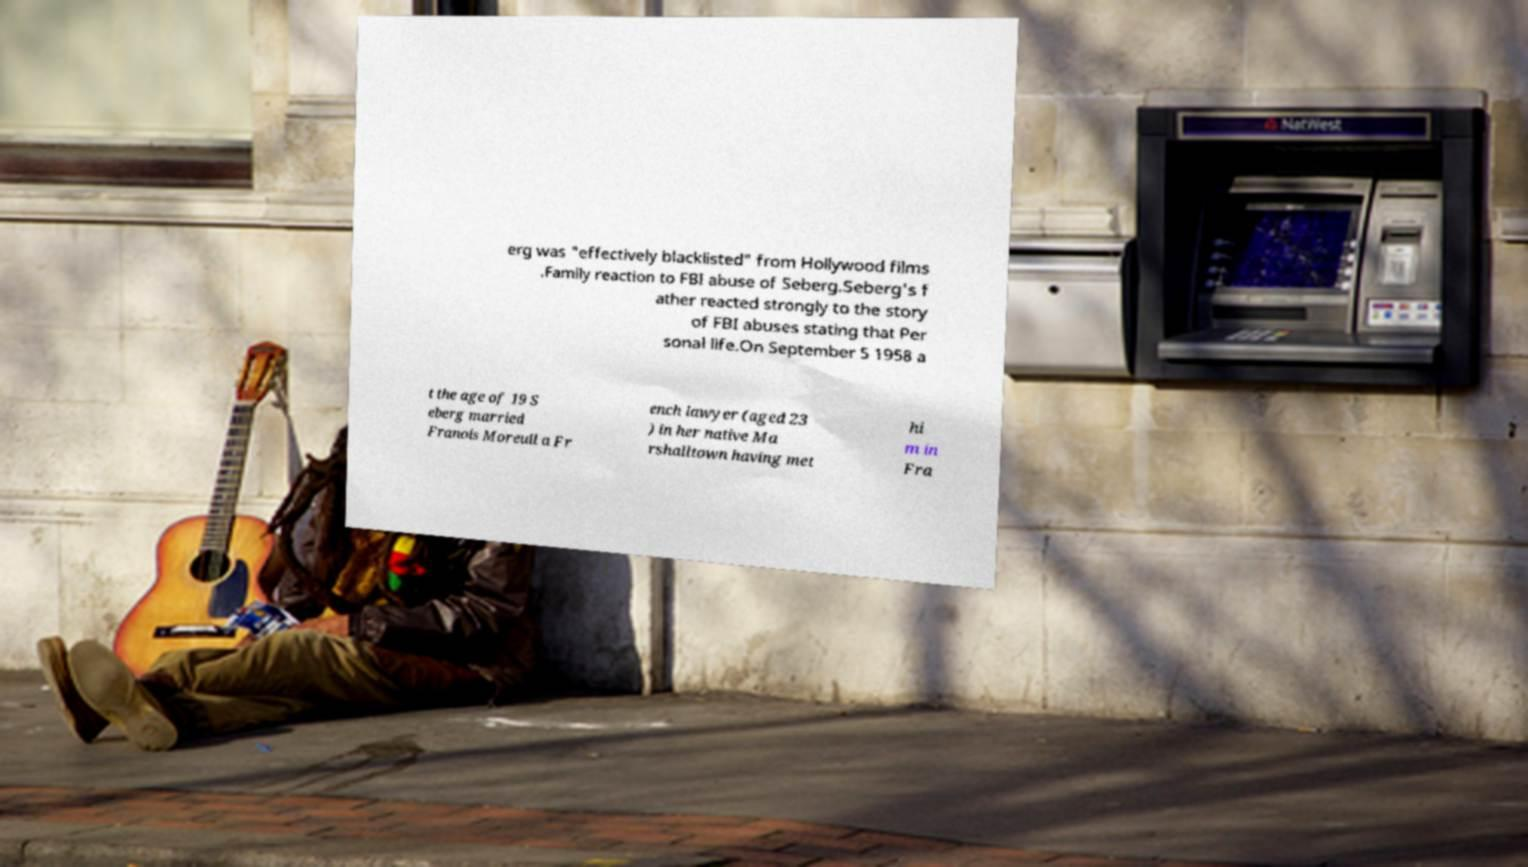Please identify and transcribe the text found in this image. erg was "effectively blacklisted" from Hollywood films .Family reaction to FBI abuse of Seberg.Seberg's f ather reacted strongly to the story of FBI abuses stating that Per sonal life.On September 5 1958 a t the age of 19 S eberg married Franois Moreuil a Fr ench lawyer (aged 23 ) in her native Ma rshalltown having met hi m in Fra 